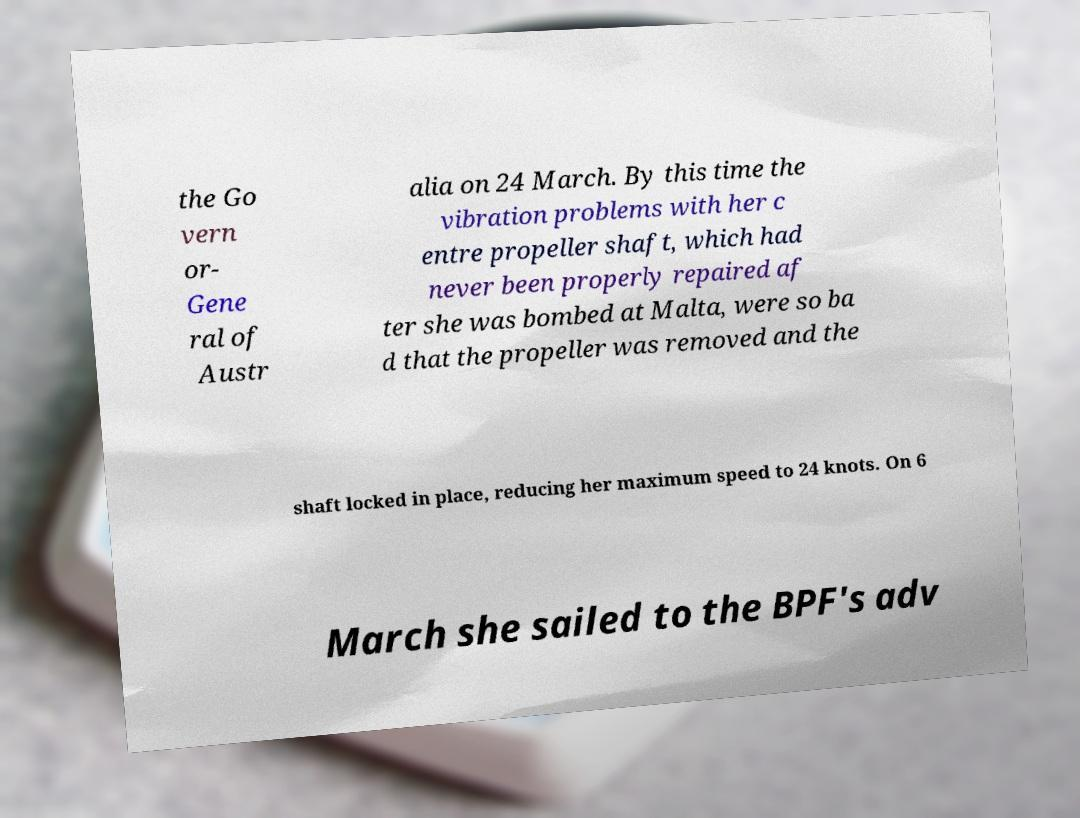Could you assist in decoding the text presented in this image and type it out clearly? the Go vern or- Gene ral of Austr alia on 24 March. By this time the vibration problems with her c entre propeller shaft, which had never been properly repaired af ter she was bombed at Malta, were so ba d that the propeller was removed and the shaft locked in place, reducing her maximum speed to 24 knots. On 6 March she sailed to the BPF's adv 